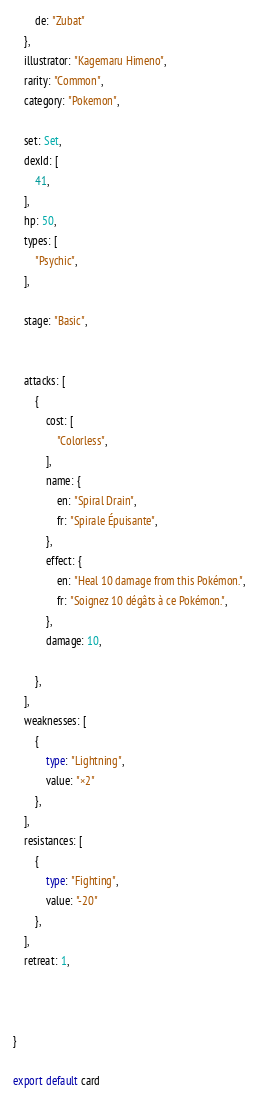<code> <loc_0><loc_0><loc_500><loc_500><_TypeScript_>		de: "Zubat"
	},
	illustrator: "Kagemaru Himeno",
	rarity: "Common",
	category: "Pokemon",

	set: Set,
	dexId: [
		41,
	],
	hp: 50,
	types: [
		"Psychic",
	],

	stage: "Basic",


	attacks: [
		{
			cost: [
				"Colorless",
			],
			name: {
				en: "Spiral Drain",
				fr: "Spirale Épuisante",
			},
			effect: {
				en: "Heal 10 damage from this Pokémon.",
				fr: "Soignez 10 dégâts à ce Pokémon.",
			},
			damage: 10,

		},
	],
	weaknesses: [
		{
			type: "Lightning",
			value: "×2"
		},
	],
	resistances: [
		{
			type: "Fighting",
			value: "-20"
		},
	],
	retreat: 1,



}

export default card
</code> 